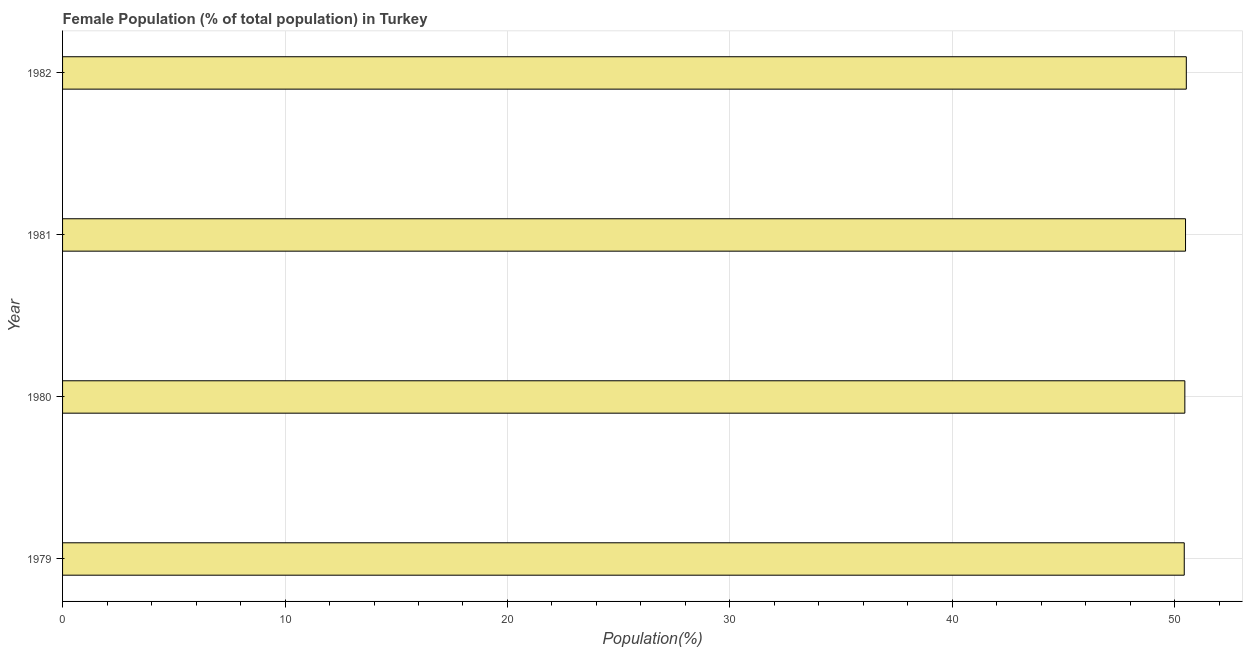Does the graph contain any zero values?
Provide a succinct answer. No. Does the graph contain grids?
Your response must be concise. Yes. What is the title of the graph?
Your answer should be compact. Female Population (% of total population) in Turkey. What is the label or title of the X-axis?
Make the answer very short. Population(%). What is the label or title of the Y-axis?
Provide a short and direct response. Year. What is the female population in 1982?
Provide a succinct answer. 50.52. Across all years, what is the maximum female population?
Keep it short and to the point. 50.52. Across all years, what is the minimum female population?
Ensure brevity in your answer.  50.42. In which year was the female population maximum?
Make the answer very short. 1982. In which year was the female population minimum?
Your response must be concise. 1979. What is the sum of the female population?
Give a very brief answer. 201.87. What is the difference between the female population in 1979 and 1982?
Keep it short and to the point. -0.09. What is the average female population per year?
Make the answer very short. 50.47. What is the median female population?
Give a very brief answer. 50.47. Is the difference between the female population in 1979 and 1981 greater than the difference between any two years?
Make the answer very short. No. What is the difference between the highest and the second highest female population?
Your response must be concise. 0.04. Is the sum of the female population in 1979 and 1981 greater than the maximum female population across all years?
Keep it short and to the point. Yes. What is the difference between the highest and the lowest female population?
Provide a succinct answer. 0.09. How many years are there in the graph?
Give a very brief answer. 4. Are the values on the major ticks of X-axis written in scientific E-notation?
Offer a terse response. No. What is the Population(%) in 1979?
Ensure brevity in your answer.  50.42. What is the Population(%) of 1980?
Offer a terse response. 50.45. What is the Population(%) in 1981?
Provide a short and direct response. 50.48. What is the Population(%) in 1982?
Make the answer very short. 50.52. What is the difference between the Population(%) in 1979 and 1980?
Make the answer very short. -0.03. What is the difference between the Population(%) in 1979 and 1981?
Give a very brief answer. -0.06. What is the difference between the Population(%) in 1979 and 1982?
Your answer should be very brief. -0.09. What is the difference between the Population(%) in 1980 and 1981?
Offer a terse response. -0.03. What is the difference between the Population(%) in 1980 and 1982?
Your answer should be compact. -0.07. What is the difference between the Population(%) in 1981 and 1982?
Keep it short and to the point. -0.03. What is the ratio of the Population(%) in 1979 to that in 1980?
Offer a terse response. 1. What is the ratio of the Population(%) in 1979 to that in 1981?
Keep it short and to the point. 1. What is the ratio of the Population(%) in 1979 to that in 1982?
Make the answer very short. 1. What is the ratio of the Population(%) in 1980 to that in 1981?
Your answer should be compact. 1. What is the ratio of the Population(%) in 1981 to that in 1982?
Offer a terse response. 1. 